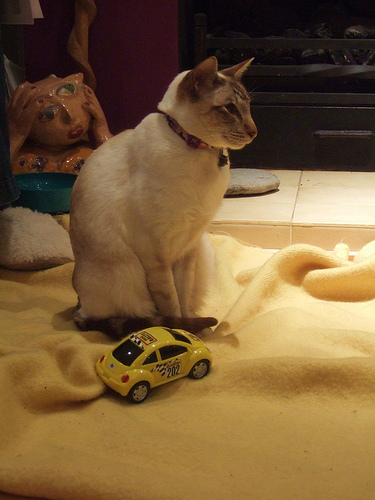How many cats are in the picture? There is one cat in the picture. It has a creamy white coat with darker points, which are characteristic of certain breeds like the Siamese. The cat is wearing a purple collar, suggesting it's a pet, and it's sitting next to a miniature yellow car toy on a soft beige blanket. 